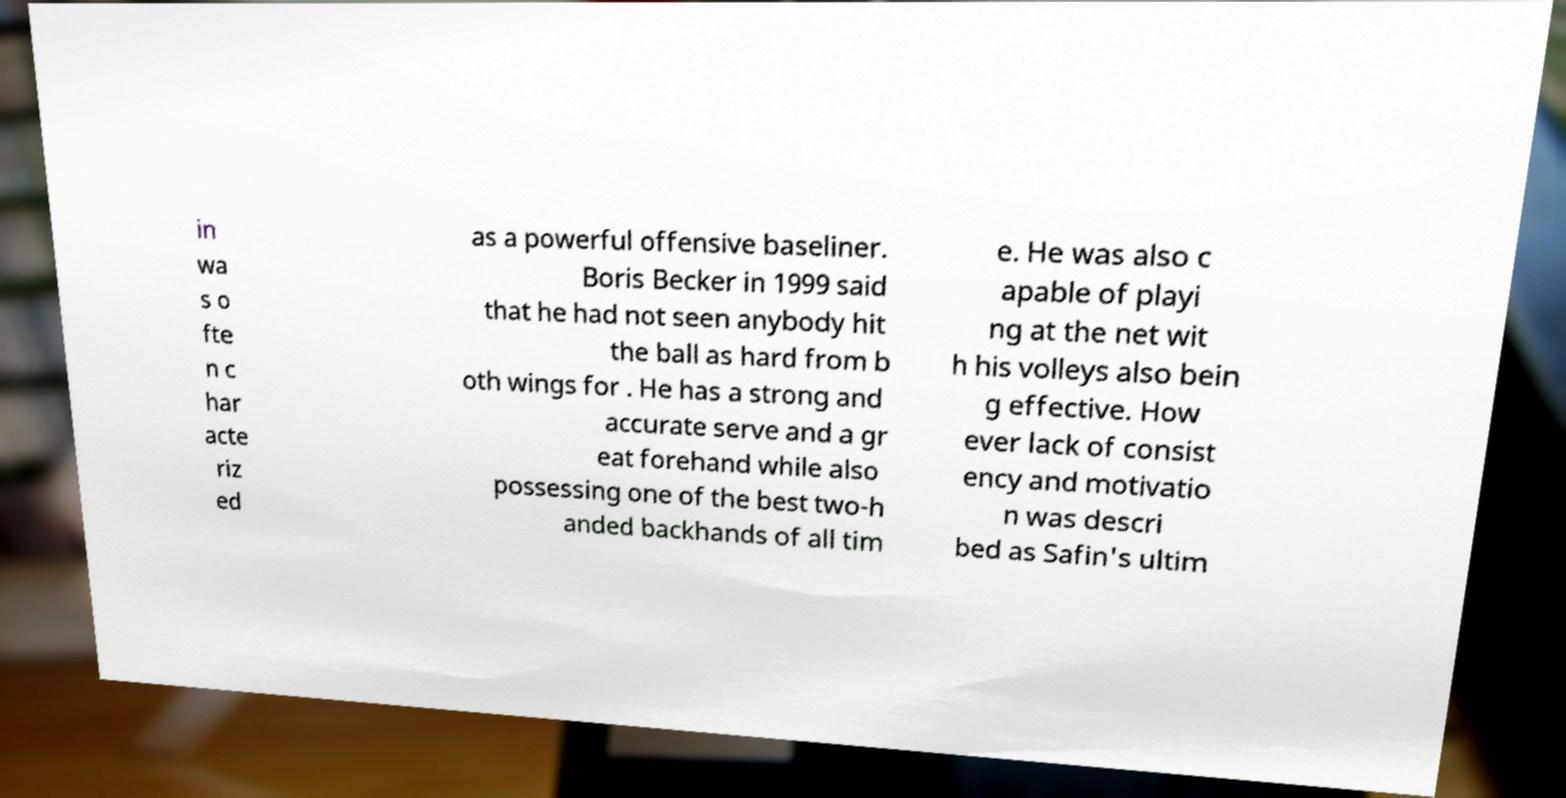I need the written content from this picture converted into text. Can you do that? in wa s o fte n c har acte riz ed as a powerful offensive baseliner. Boris Becker in 1999 said that he had not seen anybody hit the ball as hard from b oth wings for . He has a strong and accurate serve and a gr eat forehand while also possessing one of the best two-h anded backhands of all tim e. He was also c apable of playi ng at the net wit h his volleys also bein g effective. How ever lack of consist ency and motivatio n was descri bed as Safin's ultim 